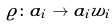<formula> <loc_0><loc_0><loc_500><loc_500>\varrho \colon a _ { i } \to a _ { i } w _ { i }</formula> 